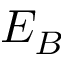<formula> <loc_0><loc_0><loc_500><loc_500>E _ { B }</formula> 